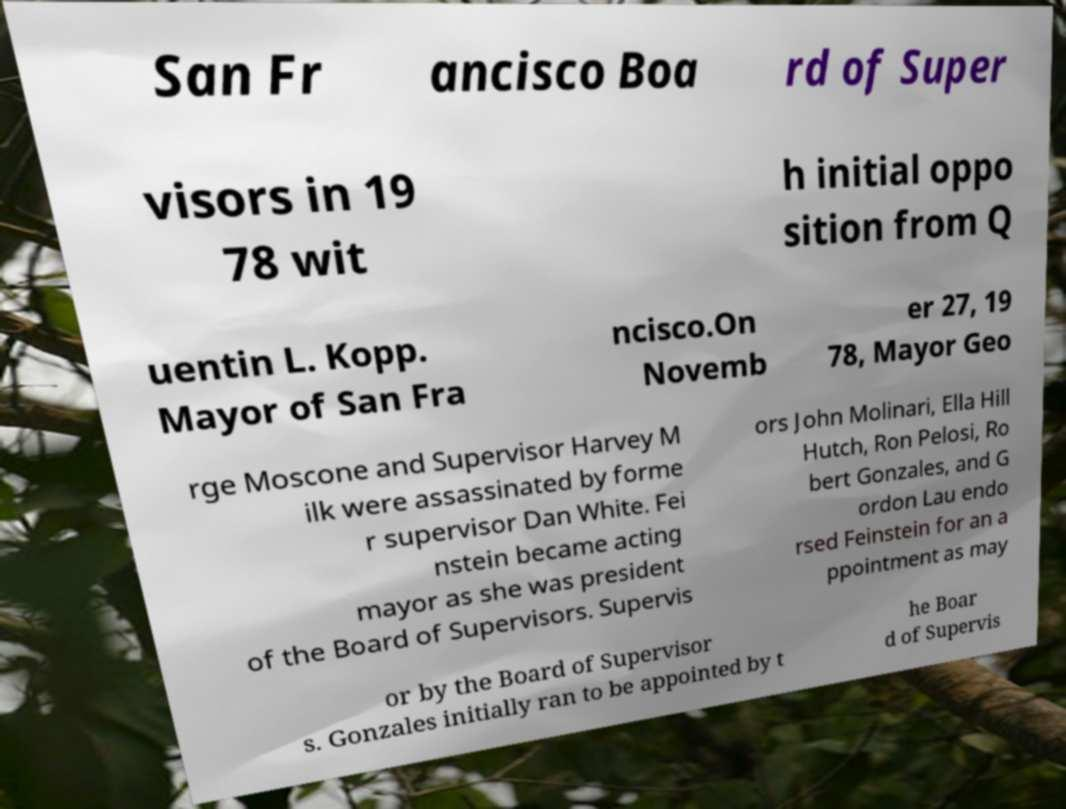Could you assist in decoding the text presented in this image and type it out clearly? San Fr ancisco Boa rd of Super visors in 19 78 wit h initial oppo sition from Q uentin L. Kopp. Mayor of San Fra ncisco.On Novemb er 27, 19 78, Mayor Geo rge Moscone and Supervisor Harvey M ilk were assassinated by forme r supervisor Dan White. Fei nstein became acting mayor as she was president of the Board of Supervisors. Supervis ors John Molinari, Ella Hill Hutch, Ron Pelosi, Ro bert Gonzales, and G ordon Lau endo rsed Feinstein for an a ppointment as may or by the Board of Supervisor s. Gonzales initially ran to be appointed by t he Boar d of Supervis 